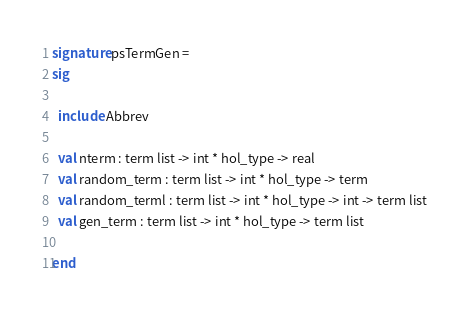Convert code to text. <code><loc_0><loc_0><loc_500><loc_500><_SML_>signature psTermGen =
sig

  include Abbrev

  val nterm : term list -> int * hol_type -> real
  val random_term : term list -> int * hol_type -> term
  val random_terml : term list -> int * hol_type -> int -> term list
  val gen_term : term list -> int * hol_type -> term list

end
</code> 